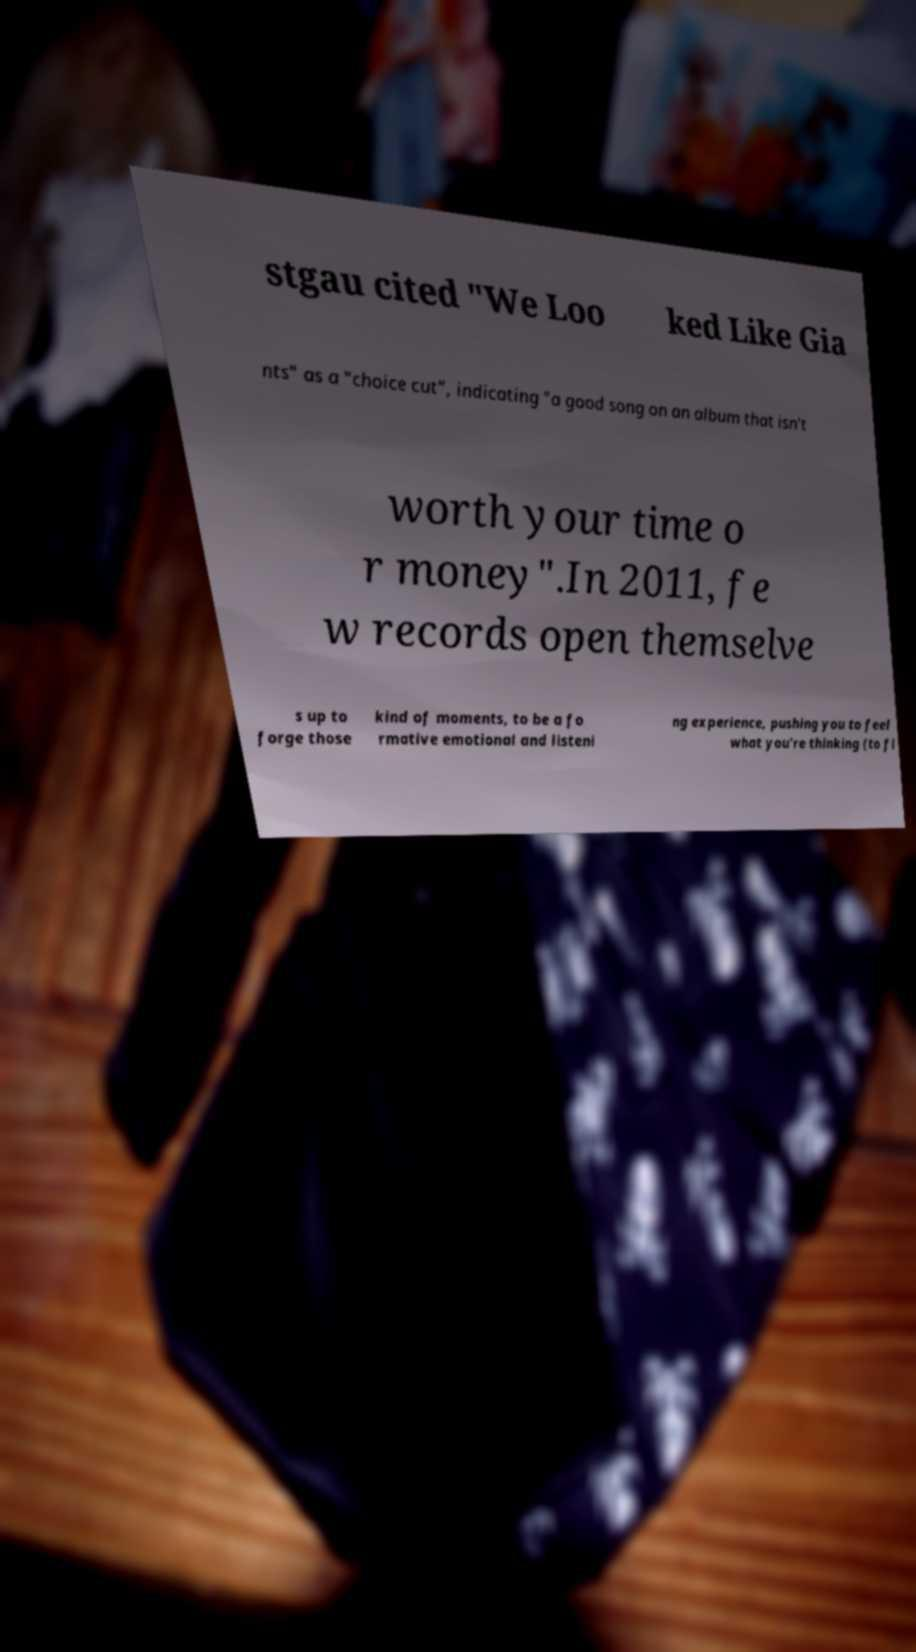Can you read and provide the text displayed in the image?This photo seems to have some interesting text. Can you extract and type it out for me? stgau cited "We Loo ked Like Gia nts" as a "choice cut", indicating "a good song on an album that isn't worth your time o r money".In 2011, fe w records open themselve s up to forge those kind of moments, to be a fo rmative emotional and listeni ng experience, pushing you to feel what you're thinking (to fl 